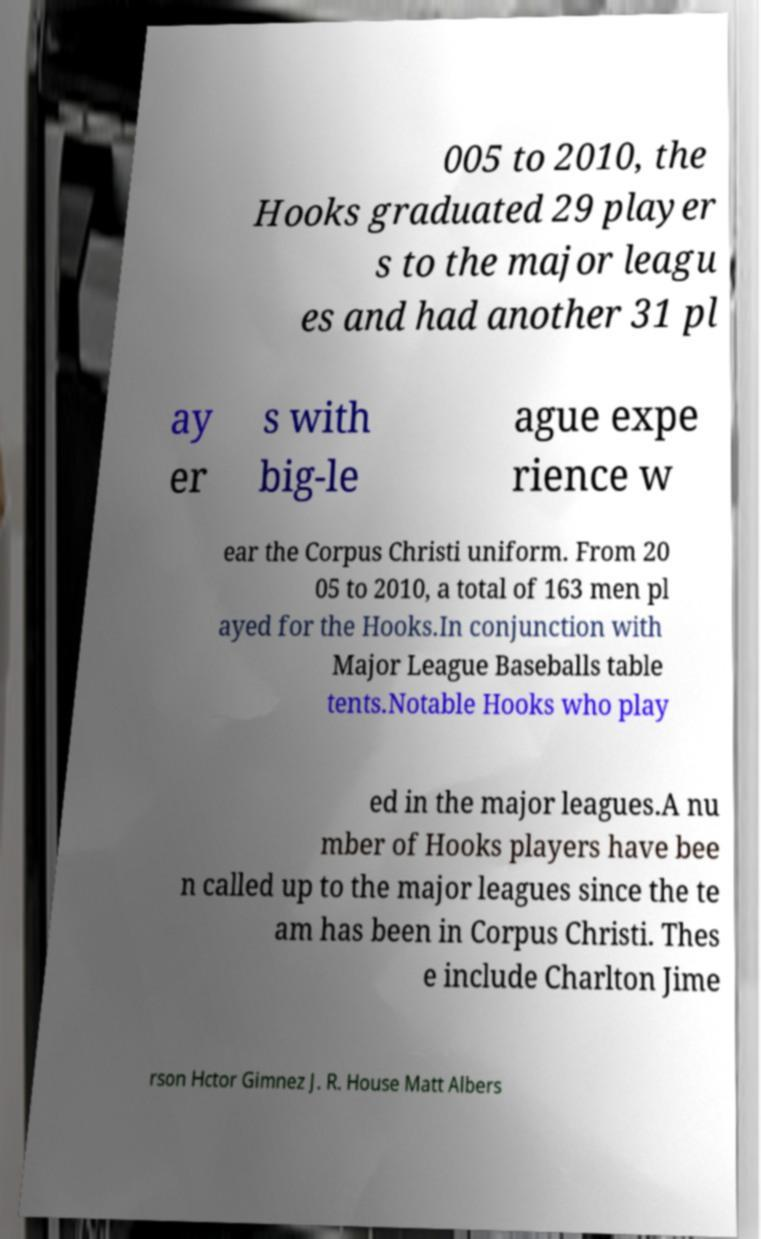Could you assist in decoding the text presented in this image and type it out clearly? 005 to 2010, the Hooks graduated 29 player s to the major leagu es and had another 31 pl ay er s with big-le ague expe rience w ear the Corpus Christi uniform. From 20 05 to 2010, a total of 163 men pl ayed for the Hooks.In conjunction with Major League Baseballs table tents.Notable Hooks who play ed in the major leagues.A nu mber of Hooks players have bee n called up to the major leagues since the te am has been in Corpus Christi. Thes e include Charlton Jime rson Hctor Gimnez J. R. House Matt Albers 